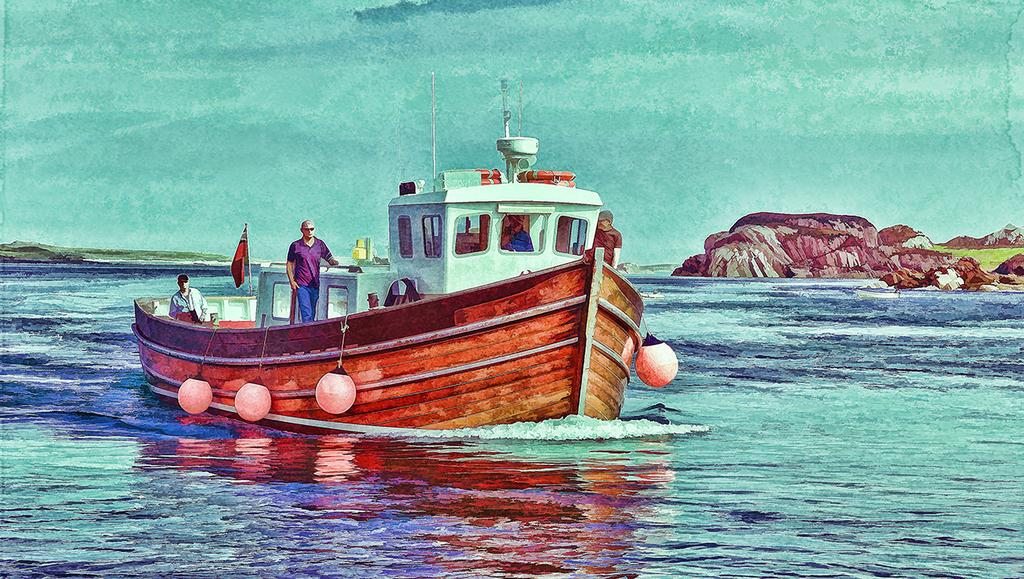What is depicted in the image? There is a sketch of persons in the image. What are the persons doing in the sketch? The persons are floating on a boat. Where is the boat located? The boat is on a river. What can be seen on the right side of the image? There is a mountain on the right side of the image. What is visible in the background of the image? There is a sky visible in the background of the image. How many memories can be seen floating in the river in the image? There are no memories present in the image; it features a sketch of persons floating on a boat on a river. 